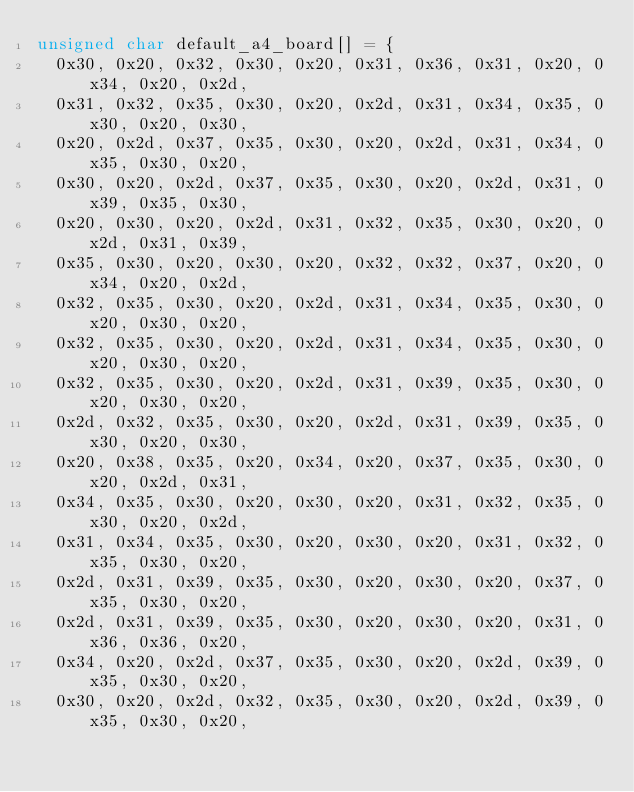<code> <loc_0><loc_0><loc_500><loc_500><_C_>unsigned char default_a4_board[] = {
  0x30, 0x20, 0x32, 0x30, 0x20, 0x31, 0x36, 0x31, 0x20, 0x34, 0x20, 0x2d,
  0x31, 0x32, 0x35, 0x30, 0x20, 0x2d, 0x31, 0x34, 0x35, 0x30, 0x20, 0x30,
  0x20, 0x2d, 0x37, 0x35, 0x30, 0x20, 0x2d, 0x31, 0x34, 0x35, 0x30, 0x20,
  0x30, 0x20, 0x2d, 0x37, 0x35, 0x30, 0x20, 0x2d, 0x31, 0x39, 0x35, 0x30,
  0x20, 0x30, 0x20, 0x2d, 0x31, 0x32, 0x35, 0x30, 0x20, 0x2d, 0x31, 0x39,
  0x35, 0x30, 0x20, 0x30, 0x20, 0x32, 0x32, 0x37, 0x20, 0x34, 0x20, 0x2d,
  0x32, 0x35, 0x30, 0x20, 0x2d, 0x31, 0x34, 0x35, 0x30, 0x20, 0x30, 0x20,
  0x32, 0x35, 0x30, 0x20, 0x2d, 0x31, 0x34, 0x35, 0x30, 0x20, 0x30, 0x20,
  0x32, 0x35, 0x30, 0x20, 0x2d, 0x31, 0x39, 0x35, 0x30, 0x20, 0x30, 0x20,
  0x2d, 0x32, 0x35, 0x30, 0x20, 0x2d, 0x31, 0x39, 0x35, 0x30, 0x20, 0x30,
  0x20, 0x38, 0x35, 0x20, 0x34, 0x20, 0x37, 0x35, 0x30, 0x20, 0x2d, 0x31,
  0x34, 0x35, 0x30, 0x20, 0x30, 0x20, 0x31, 0x32, 0x35, 0x30, 0x20, 0x2d,
  0x31, 0x34, 0x35, 0x30, 0x20, 0x30, 0x20, 0x31, 0x32, 0x35, 0x30, 0x20,
  0x2d, 0x31, 0x39, 0x35, 0x30, 0x20, 0x30, 0x20, 0x37, 0x35, 0x30, 0x20,
  0x2d, 0x31, 0x39, 0x35, 0x30, 0x20, 0x30, 0x20, 0x31, 0x36, 0x36, 0x20,
  0x34, 0x20, 0x2d, 0x37, 0x35, 0x30, 0x20, 0x2d, 0x39, 0x35, 0x30, 0x20,
  0x30, 0x20, 0x2d, 0x32, 0x35, 0x30, 0x20, 0x2d, 0x39, 0x35, 0x30, 0x20,</code> 